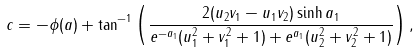Convert formula to latex. <formula><loc_0><loc_0><loc_500><loc_500>c = - \phi ( a ) + \tan ^ { - 1 } \left ( \frac { 2 ( u _ { 2 } v _ { 1 } - u _ { 1 } v _ { 2 } ) \sinh a _ { 1 } } { e ^ { - a _ { 1 } } ( u _ { 1 } ^ { 2 } + v _ { 1 } ^ { 2 } + 1 ) + e ^ { a _ { 1 } } ( u _ { 2 } ^ { 2 } + v _ { 2 } ^ { 2 } + 1 ) } \right ) ,</formula> 